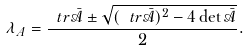<formula> <loc_0><loc_0><loc_500><loc_500>\lambda _ { A } = \frac { \ t r \bar { \mathcal { A } } \pm \sqrt { ( \ t r \bar { \mathcal { A } } ) ^ { 2 } - 4 \det \bar { \mathcal { A } } } } { 2 } .</formula> 